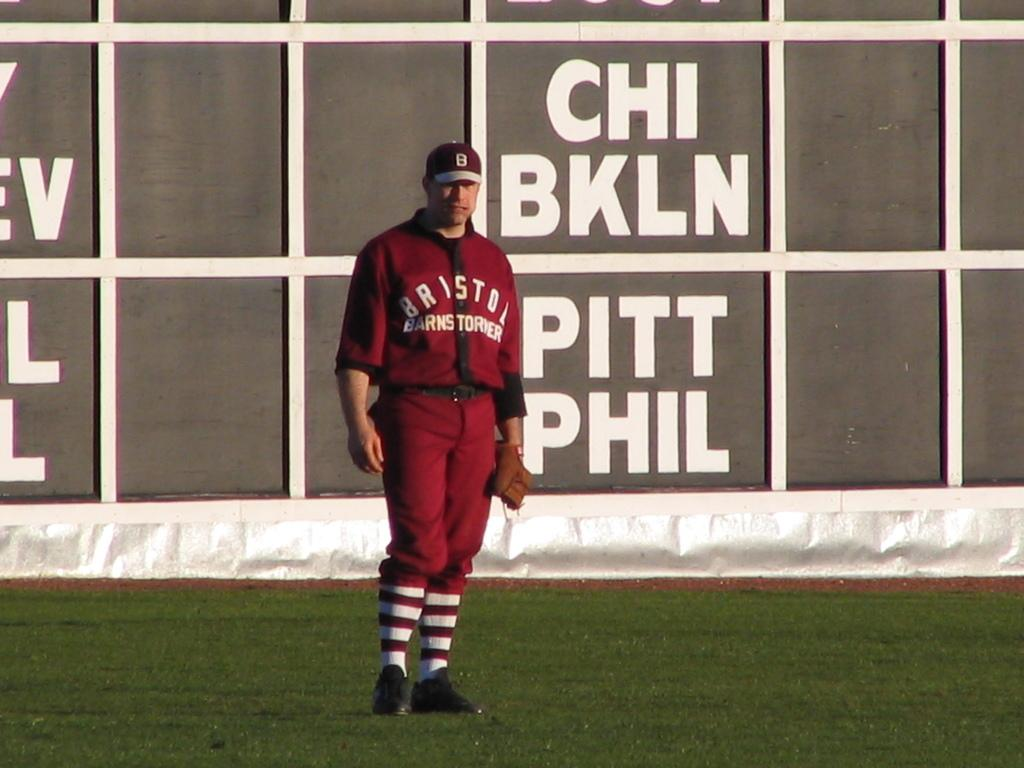<image>
Offer a succinct explanation of the picture presented. A man in a maroon Bristol Barnstormer uniform is standing on the field of play. 